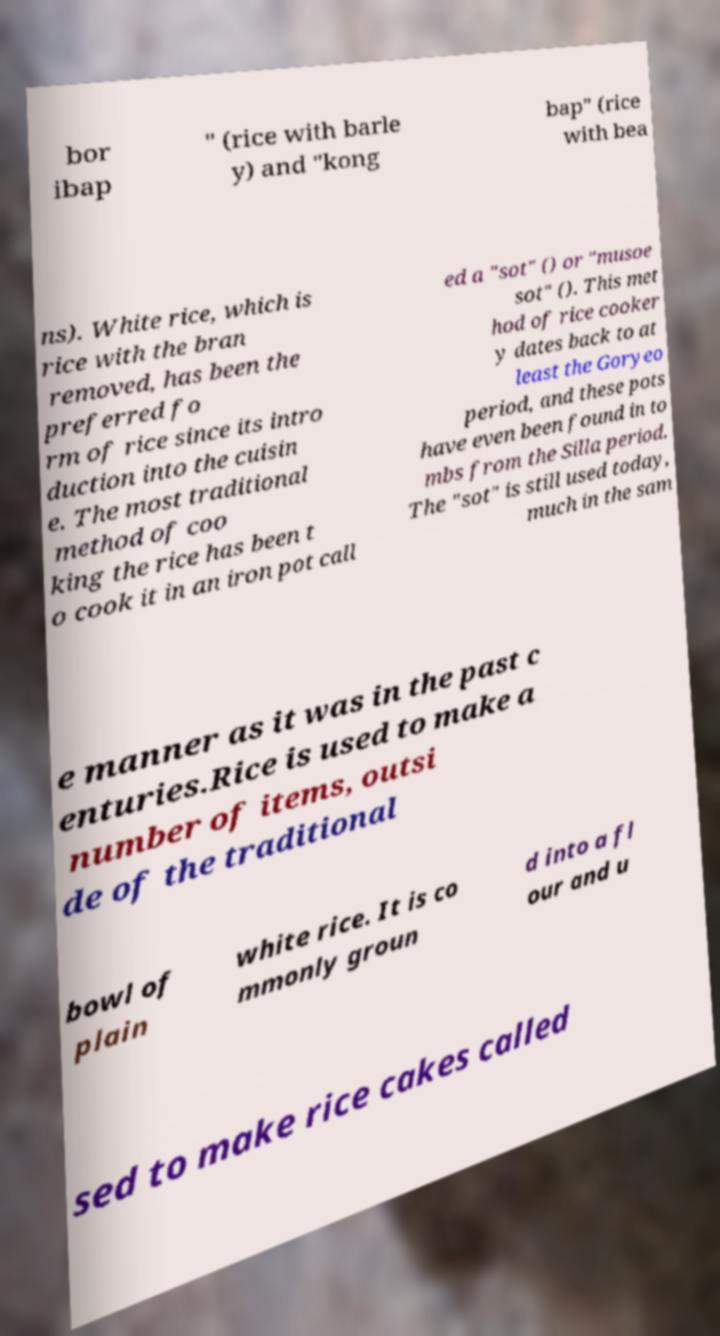For documentation purposes, I need the text within this image transcribed. Could you provide that? bor ibap " (rice with barle y) and "kong bap" (rice with bea ns). White rice, which is rice with the bran removed, has been the preferred fo rm of rice since its intro duction into the cuisin e. The most traditional method of coo king the rice has been t o cook it in an iron pot call ed a "sot" () or "musoe sot" (). This met hod of rice cooker y dates back to at least the Goryeo period, and these pots have even been found in to mbs from the Silla period. The "sot" is still used today, much in the sam e manner as it was in the past c enturies.Rice is used to make a number of items, outsi de of the traditional bowl of plain white rice. It is co mmonly groun d into a fl our and u sed to make rice cakes called 